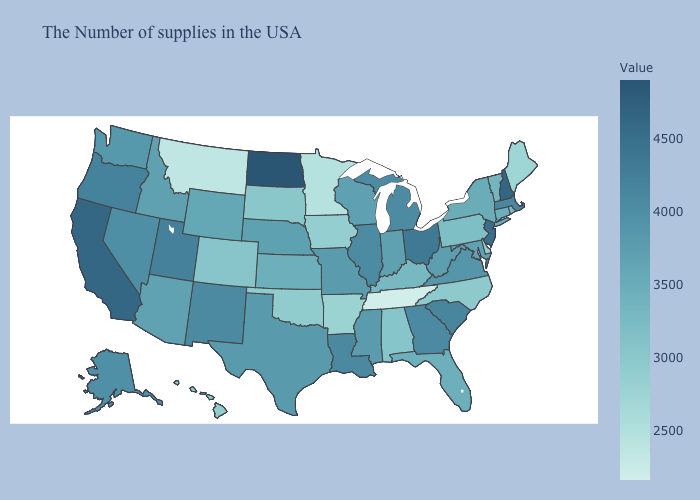Does Indiana have the highest value in the MidWest?
Answer briefly. No. Among the states that border Oklahoma , which have the highest value?
Short answer required. New Mexico. Does Hawaii have a higher value than Florida?
Keep it brief. No. Is the legend a continuous bar?
Quick response, please. Yes. Does Nevada have a higher value than New Jersey?
Short answer required. No. Does the map have missing data?
Short answer required. No. Is the legend a continuous bar?
Quick response, please. Yes. Does Hawaii have the highest value in the West?
Keep it brief. No. 